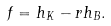<formula> <loc_0><loc_0><loc_500><loc_500>f = h _ { K } - r h _ { B } .</formula> 